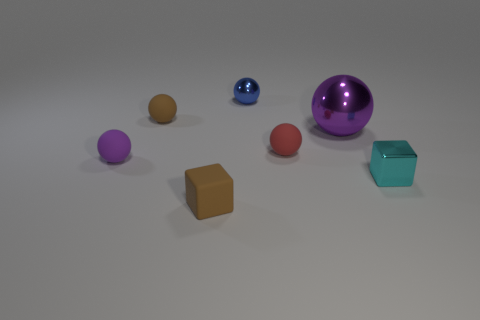Subtract 1 balls. How many balls are left? 4 Subtract all brown balls. How many balls are left? 4 Subtract all small brown spheres. How many spheres are left? 4 Subtract all green balls. Subtract all gray blocks. How many balls are left? 5 Add 3 small blue things. How many objects exist? 10 Subtract all spheres. How many objects are left? 2 Subtract all purple matte balls. Subtract all cyan metallic cubes. How many objects are left? 5 Add 6 tiny cyan things. How many tiny cyan things are left? 7 Add 5 brown matte balls. How many brown matte balls exist? 6 Subtract 0 blue cylinders. How many objects are left? 7 